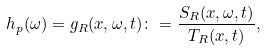<formula> <loc_0><loc_0><loc_500><loc_500>h _ { p } ( \omega ) = g _ { R } ( x , \omega , t ) \colon = \frac { S _ { R } ( x , \omega , t ) } { T _ { R } ( x , t ) } ,</formula> 